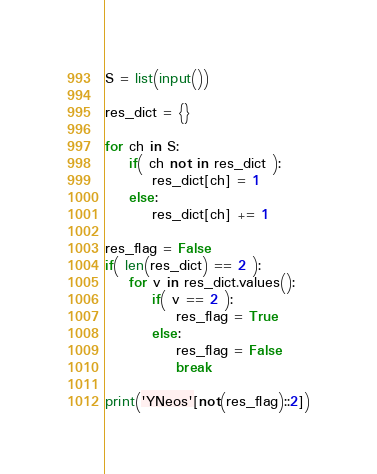<code> <loc_0><loc_0><loc_500><loc_500><_Python_>S = list(input())

res_dict = {}

for ch in S:
    if( ch not in res_dict ):
        res_dict[ch] = 1
    else:
        res_dict[ch] += 1

res_flag = False
if( len(res_dict) == 2 ):
    for v in res_dict.values():
        if( v == 2 ):
            res_flag = True
        else:
            res_flag = False
            break

print('YNeos'[not(res_flag)::2])</code> 